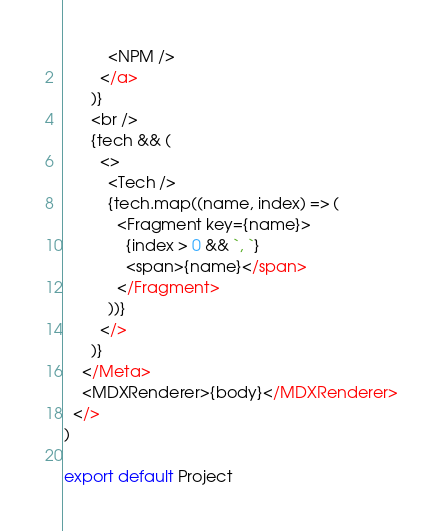Convert code to text. <code><loc_0><loc_0><loc_500><loc_500><_JavaScript_>          <NPM />
        </a>
      )}
      <br />
      {tech && (
        <>
          <Tech />
          {tech.map((name, index) => (
            <Fragment key={name}>
              {index > 0 && `, `}
              <span>{name}</span>
            </Fragment>
          ))}
        </>
      )}
    </Meta>
    <MDXRenderer>{body}</MDXRenderer>
  </>
)

export default Project
</code> 